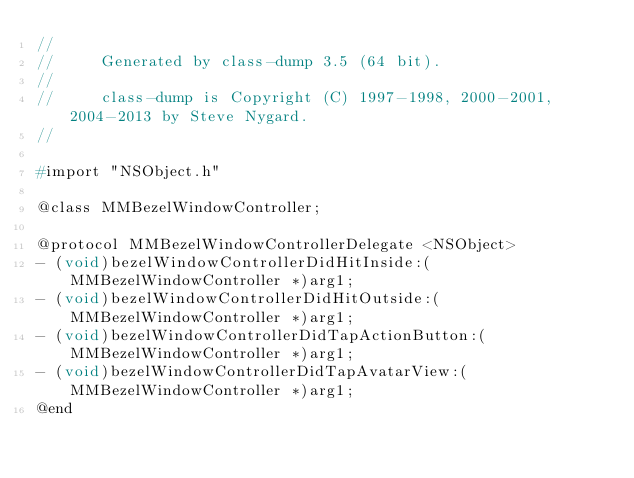Convert code to text. <code><loc_0><loc_0><loc_500><loc_500><_C_>//
//     Generated by class-dump 3.5 (64 bit).
//
//     class-dump is Copyright (C) 1997-1998, 2000-2001, 2004-2013 by Steve Nygard.
//

#import "NSObject.h"

@class MMBezelWindowController;

@protocol MMBezelWindowControllerDelegate <NSObject>
- (void)bezelWindowControllerDidHitInside:(MMBezelWindowController *)arg1;
- (void)bezelWindowControllerDidHitOutside:(MMBezelWindowController *)arg1;
- (void)bezelWindowControllerDidTapActionButton:(MMBezelWindowController *)arg1;
- (void)bezelWindowControllerDidTapAvatarView:(MMBezelWindowController *)arg1;
@end

</code> 